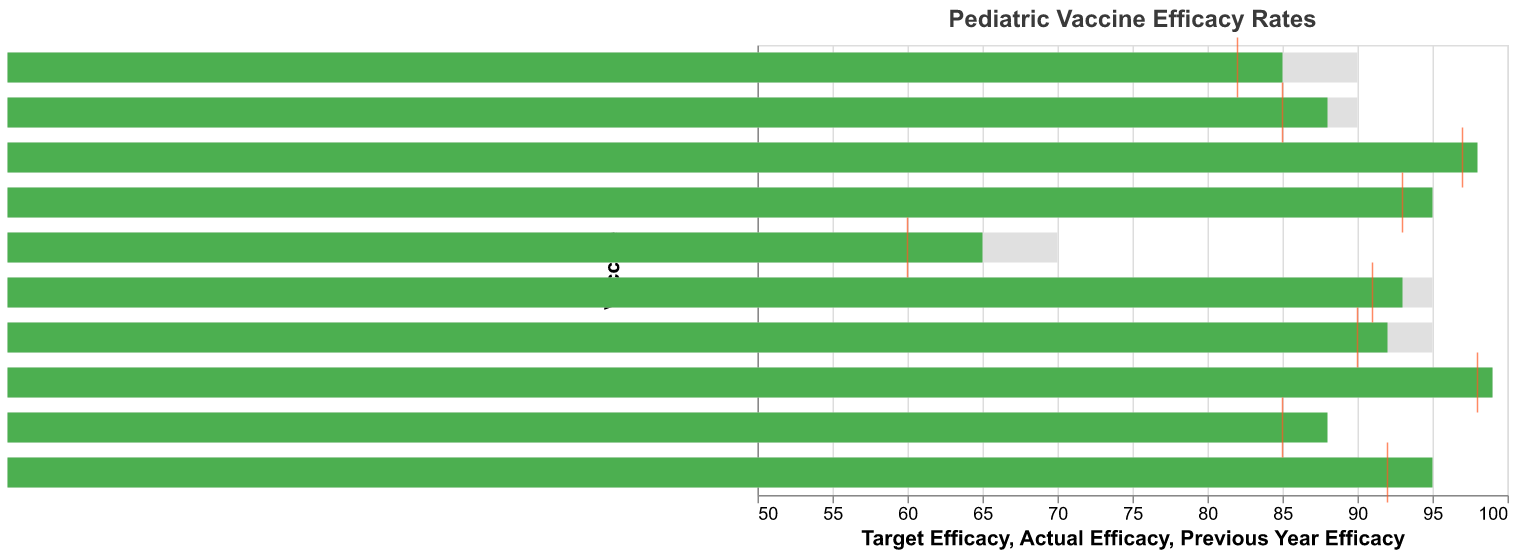What is the title of the chart? The title of the chart is typically displayed at the top of the figure. In this chart, it is clearly labeled.
Answer: Pediatric Vaccine Efficacy Rates Which vaccine has the highest actual efficacy rate? To find this, look at the green bars representing the actual efficacy rate. Compare each bar to determine the highest one.
Answer: Polio How many vaccines met or exceeded their target efficacy? Compare the length of each green bar (Actual Efficacy) to the gray bar (Target Efficacy). Count the instances where the green bar is equal to or exceeds the gray bar.
Answer: 5 Which vaccine shows the highest improvement in efficacy from the previous year? Calculate the difference between the "Previous Year Efficacy" (red tick marks) and the "Actual Efficacy" (green bars) for each vaccine. The highest difference identifies the vaccine with the most improvement.
Answer: Influenza What is the average target efficacy rate across all vaccines? Add up the target efficacy rates for all vaccines, then divide by the number of vaccines (10).
Answer: 91.4 Which vaccines did not achieve their target efficacy? Compare the green bars (actual efficacy) against the gray bars (target efficacy). Identify the vaccines where the green bar is shorter than its corresponding gray bar.
Answer: MMR, DTaP, Pneumococcal, Influenza, HPV Between MMR and DTaP, which vaccine improved more from the previous year? For each vaccine, subtract the "Previous Year Efficacy" from the "Actual Efficacy". Compare these differences for MMR and DTaP.
Answer: DTaP What is the minimum actual efficacy rate observed among the vaccines? Look for the smallest value of the green bars which represent the actual efficacy rates.
Answer: 65 How many vaccines have a previous year efficacy that is lower than their actual efficacy? Identify and count the vaccines where the green bar (actual efficacy) is higher than the red tick mark (previous year efficacy).
Answer: 7 Which vaccine surpasses its target efficacy by the largest margin? Calculate the difference between the actual efficacy and target efficacy for each vaccine. Identify the vaccine with the greatest positive difference.
Answer: Hepatitis B 